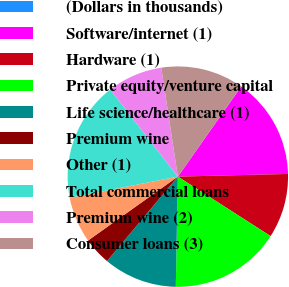Convert chart to OTSL. <chart><loc_0><loc_0><loc_500><loc_500><pie_chart><fcel>(Dollars in thousands)<fcel>Software/internet (1)<fcel>Hardware (1)<fcel>Private equity/venture capital<fcel>Life science/healthcare (1)<fcel>Premium wine<fcel>Other (1)<fcel>Total commercial loans<fcel>Premium wine (2)<fcel>Consumer loans (3)<nl><fcel>0.0%<fcel>14.86%<fcel>9.46%<fcel>16.22%<fcel>10.81%<fcel>4.05%<fcel>6.76%<fcel>17.57%<fcel>8.11%<fcel>12.16%<nl></chart> 